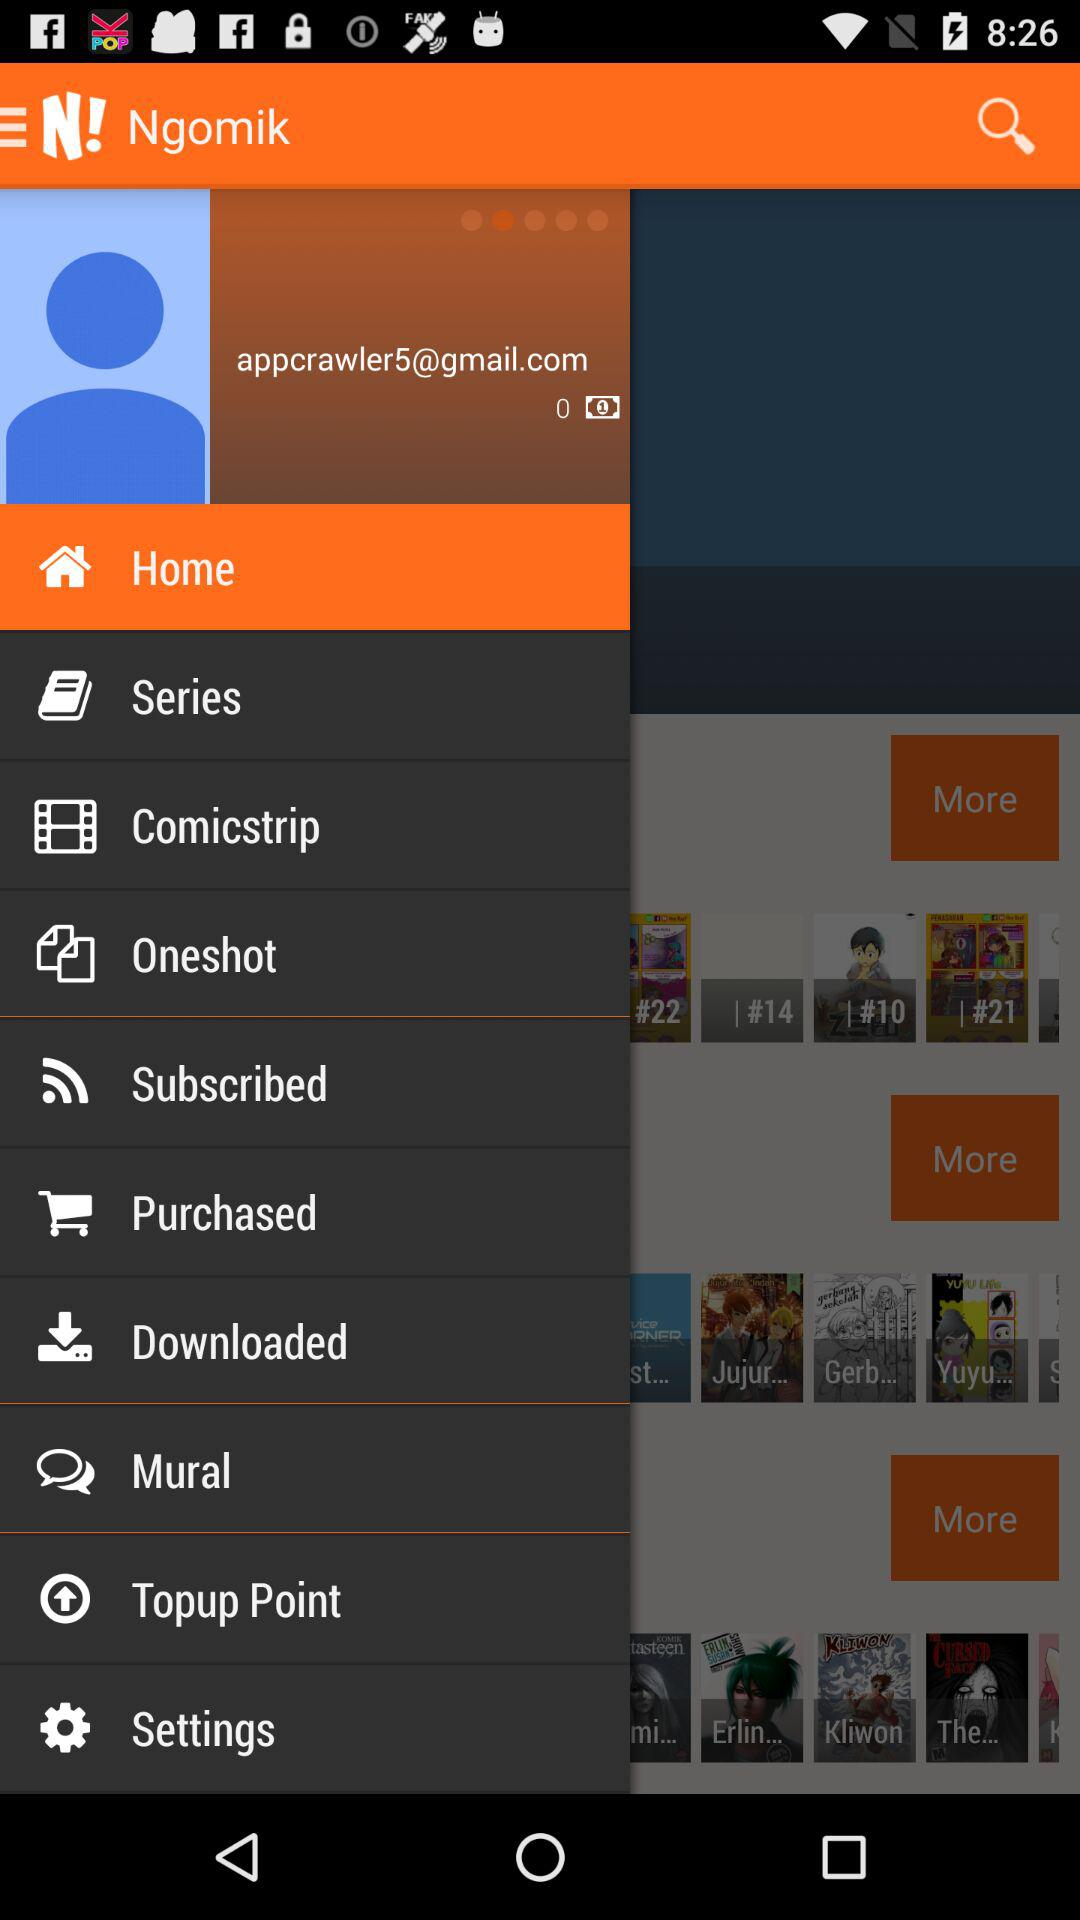Which item has been selected? The selected item is "Home". 